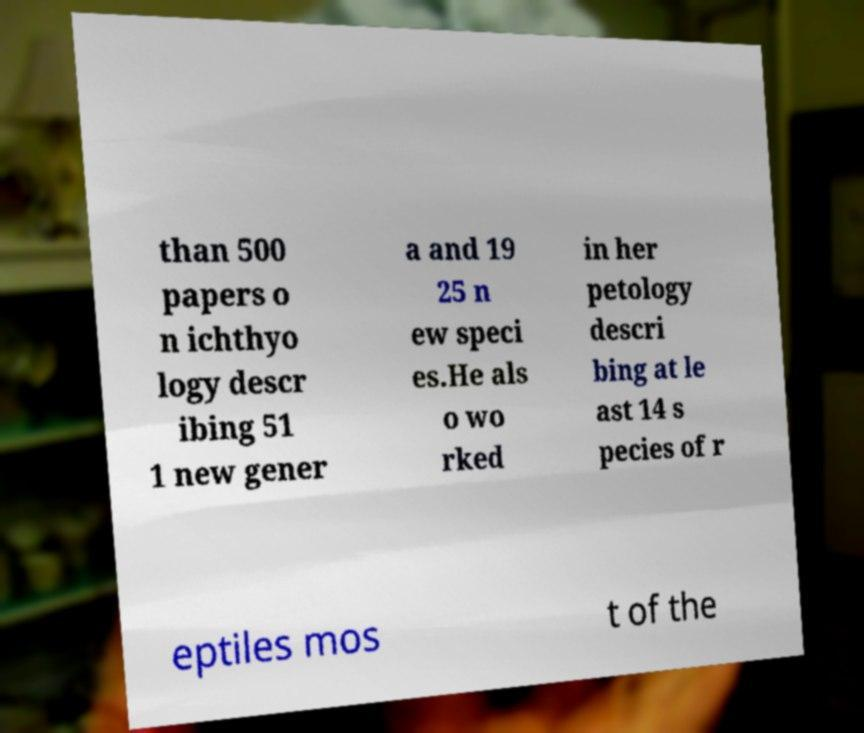Could you assist in decoding the text presented in this image and type it out clearly? than 500 papers o n ichthyo logy descr ibing 51 1 new gener a and 19 25 n ew speci es.He als o wo rked in her petology descri bing at le ast 14 s pecies of r eptiles mos t of the 